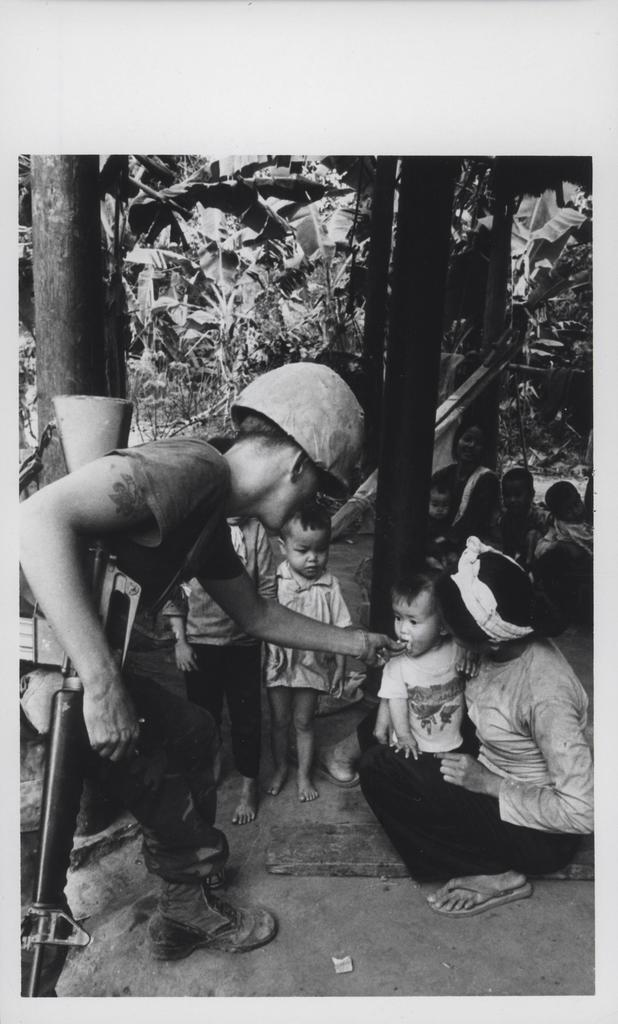What is the main action taking place in the image? The person is feeding a baby in the image. Who is holding the baby while it is being fed? The baby is in the lap of a woman. Are there any other people present in the image? Yes, there are other people standing in the image. What type of lead is the baby using to communicate with the person feeding it? There is no lead present in the image, and the baby is not using any form of communication to interact with the person feeding it. 